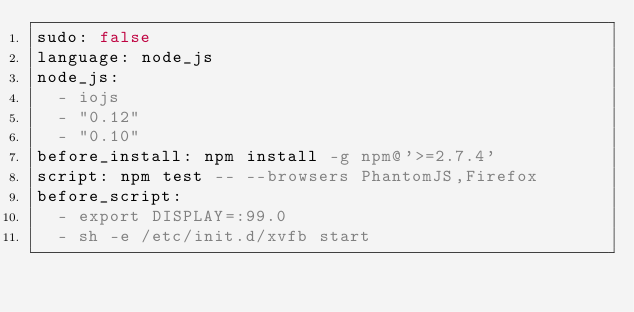<code> <loc_0><loc_0><loc_500><loc_500><_YAML_>sudo: false
language: node_js
node_js:
  - iojs
  - "0.12"
  - "0.10"
before_install: npm install -g npm@'>=2.7.4'
script: npm test -- --browsers PhantomJS,Firefox
before_script:
  - export DISPLAY=:99.0
  - sh -e /etc/init.d/xvfb start
</code> 